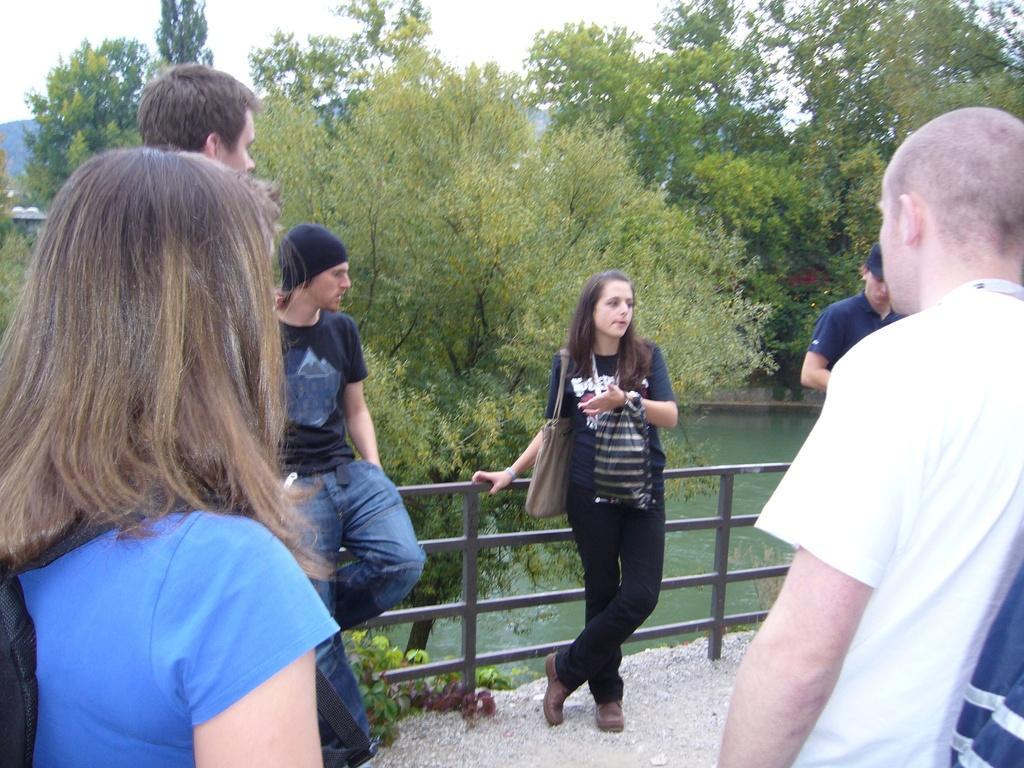Could you give a brief overview of what you see in this image? In this image, I can see a group of people standing on the path and there is a fence over here. In the background I can see lot of trees, water and the sky. 